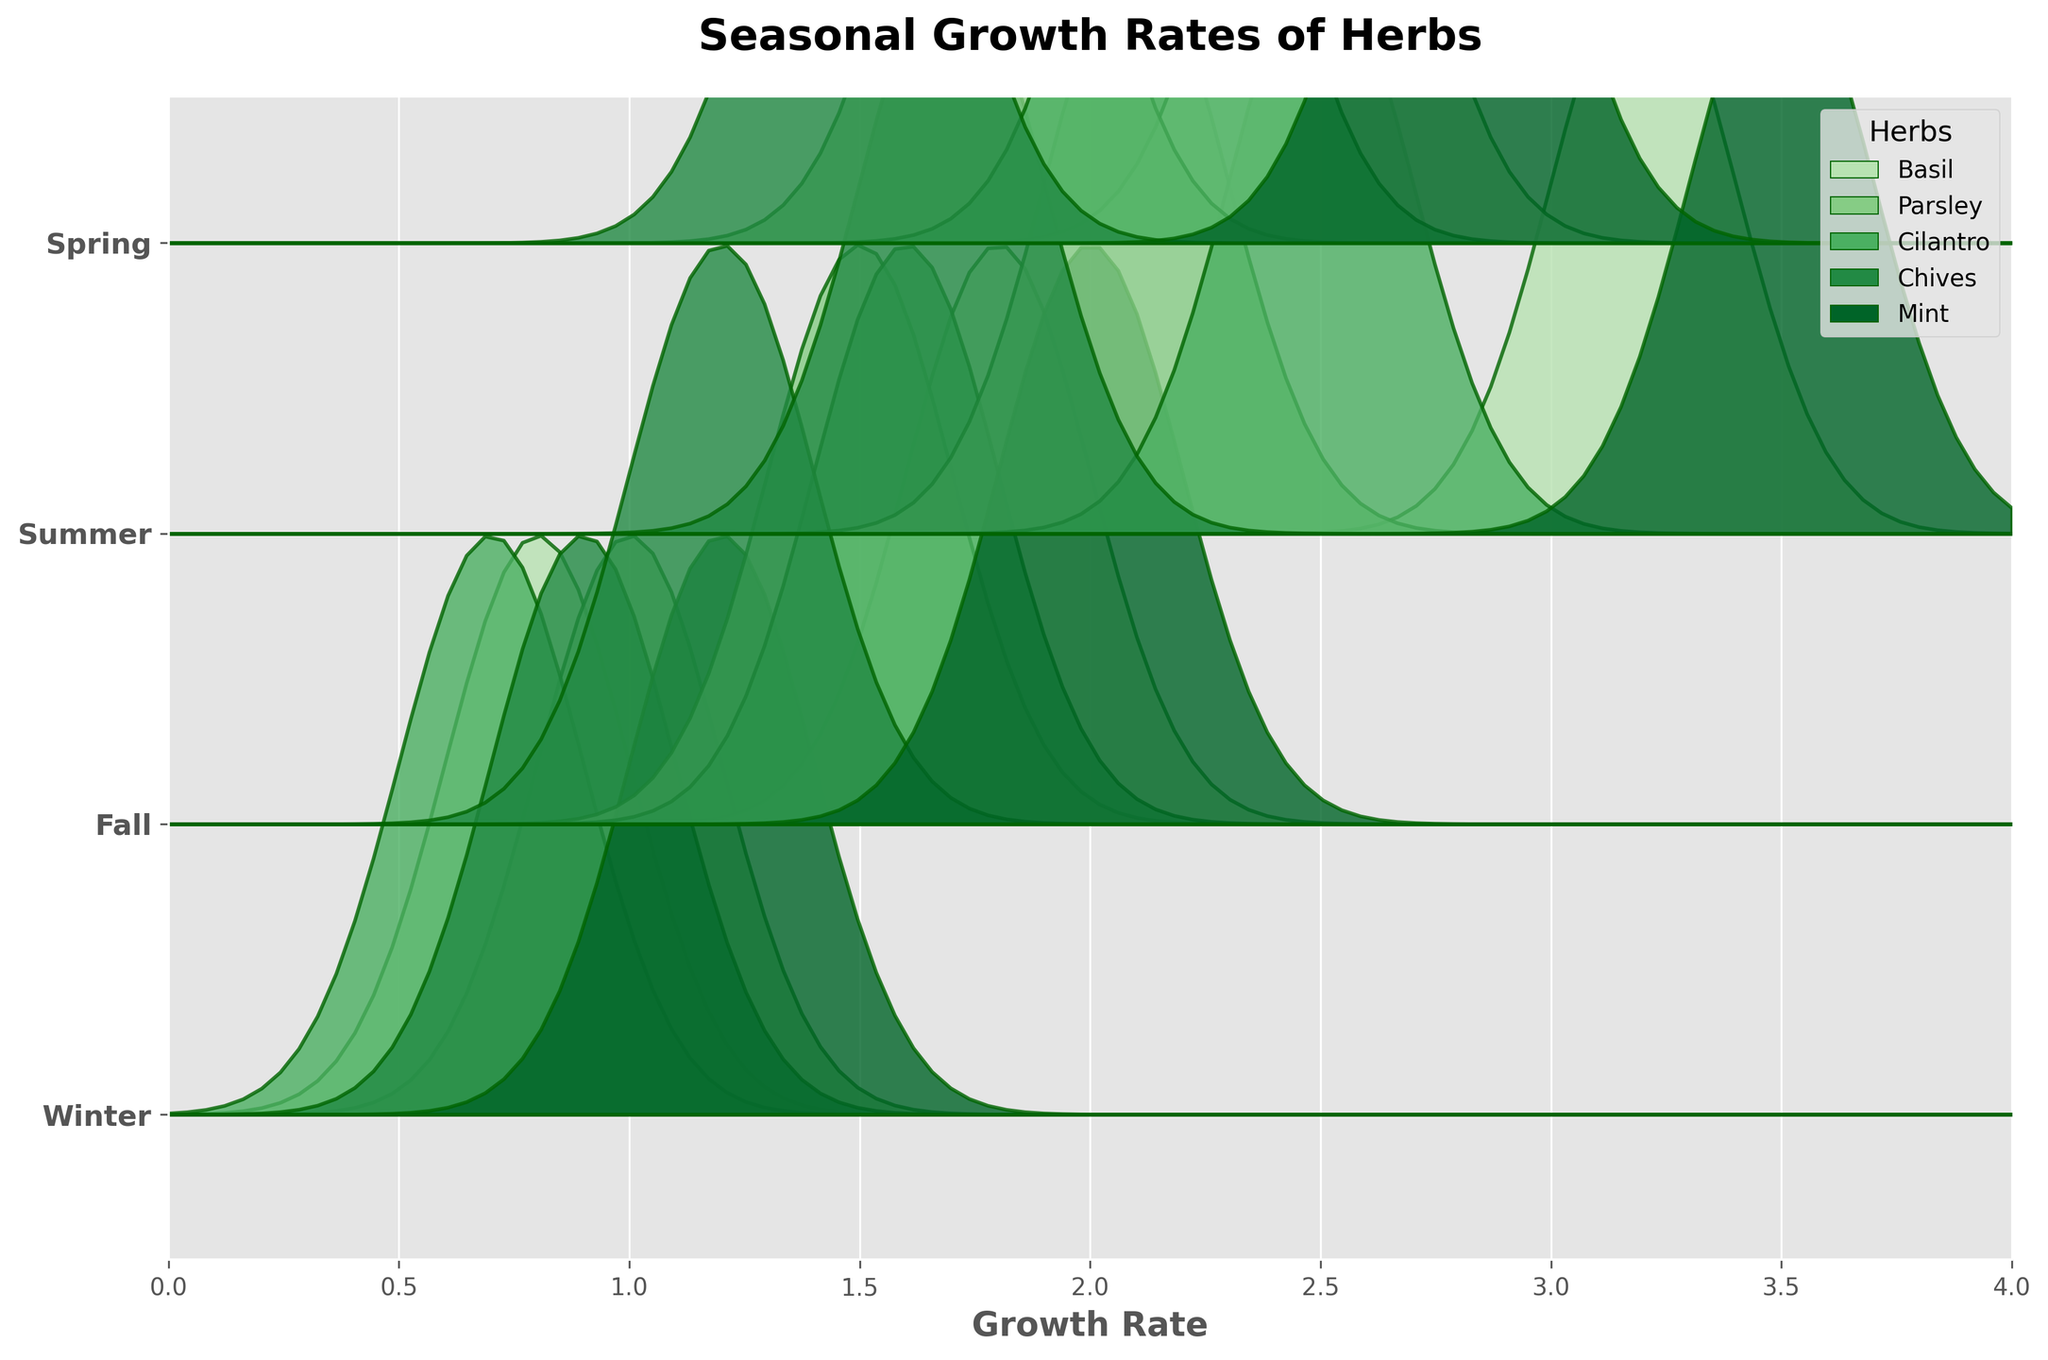Which season shows the highest overall growth rates of herbs? By examining the ridgeline plot, we can see that the growth rates are highest in the Summer, where the peaks of the density distributions are placed further to the right along the x-axis compared to other seasons
Answer: Summer How does the growth rate of Basil in Winter compare to that in Summer? Observing the peaks in the ridgeline plot for Basil in Winter and Summer, we can see that the peak for Summer is much further to the right (higher growth rate) compared to Winter
Answer: Summer is higher Which herb has the most consistent growth rate across all seasons? To find the herb with the most consistent growth rate, we look for one whose peaks are closest to the same point on the x-axis across all seasons. Mint displays relatively consistent growth across seasons, with peaks relatively closer to each other
Answer: Mint What's the range of growth rates for Parsley across all seasons (highest minus lowest)? By identifying the peaks for Parsley in each season: Summer (2.1), Spring (1.8), Fall (1.5), Winter (1.0), we calculate the range as 2.1 - 1.0
Answer: 1.1 How does the growth rate of Chives in Fall compare to that of Cilantro in Winter? Checking the ridgeline plot, the peak for Chives in Fall is at 1.2, while the peak for Cilantro in Winter is at 0.7. Chives in Fall have a higher growth rate
Answer: Chives in Fall is higher Which season has the lowest growth rate for Mint? We observe the peak positions for Mint across all seasons and notice that the peak for Winter is the furthest left, indicating the lowest growth rate
Answer: Winter If you average the growth rates of Basil across all seasons, what is the overall average growth rate? By averaging the growth rates of Basil for each season: (2.5 + 3.2 + 1.8 + 0.8) / 4, we get (8.3 / 4)
Answer: 2.075 What is the difference in growth rates between Mint in Spring and Parsley in Fall? Checking the peaks, Mint in Spring is at 2.8 and Parsley in Fall is at 1.5, so the difference is 2.8 - 1.5
Answer: 1.3 Which herb shows the largest seasonal variation from highest to lowest growth rate? From inspecting the plot, Basil has the peaks spread the most widely (Spring 2.5, Summer 3.2, Fall 1.8, Winter 0.8). The range is 3.2 - 0.8
Answer: Basil 